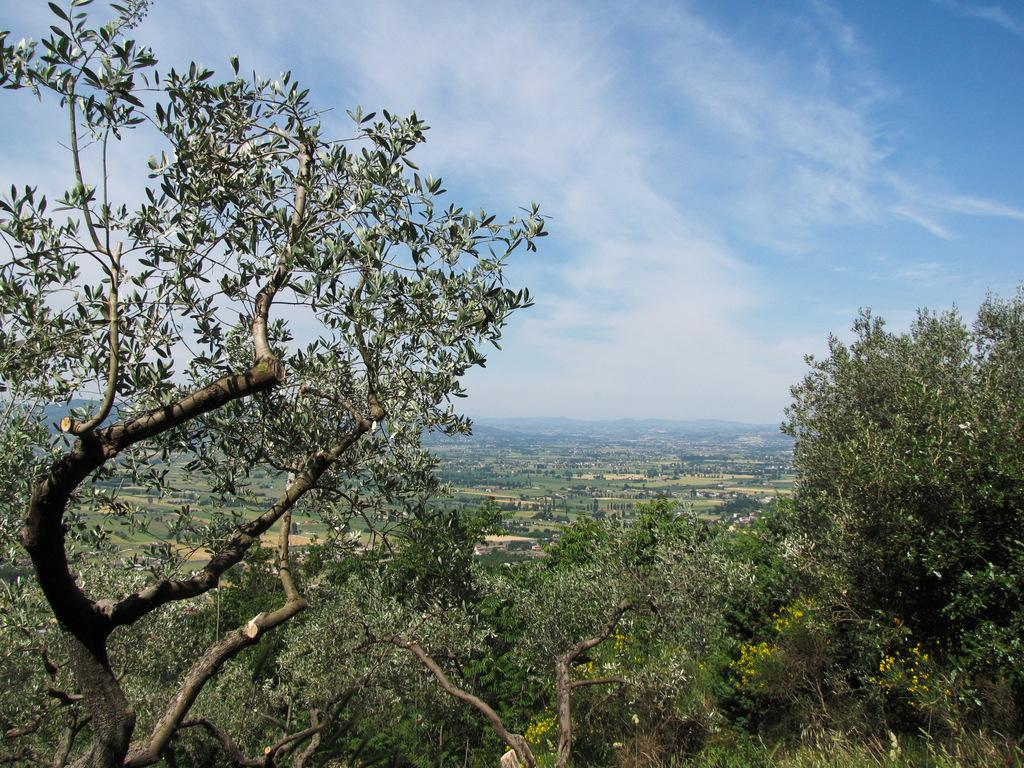What is located in the center of the image? There are trees in the center of the image. What can be seen in the background of the image? There is sky visible in the background of the image. What type of landscape feature is present in the background of the image? There are hills in the background of the image. What rate of inflation is depicted in the image? There is no reference to inflation or any financial concept in the image; it features trees, sky, and hills. 